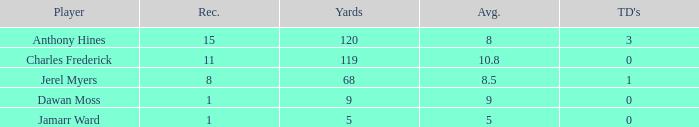What is the aggregate average when there are no touchdowns and dawan moss plays? 0.0. 